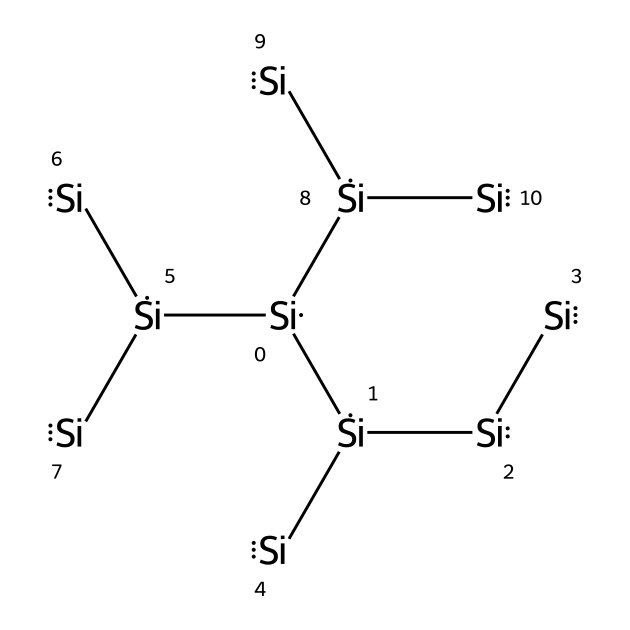What is the central atom in this structure? The SMILES representation indicates multiple silicon atoms connected in a crystalline structure. The central atom, which is consistently represented, is silicon.
Answer: silicon How many silicon atoms are in this structure? By counting the occurrences of the silicon atom symbol in the SMILES string, we find that there are ten silicon atoms total, as indicated by the nested structure.
Answer: ten What type of bonding is primarily present in this silicon structure? The structure displays covalent bonding characterized by the sharing of electrons between silicon atoms, which is typical in semiconductors due to the tetrahedral arrangement.
Answer: covalent What is the coordination number of silicon in this structure? Each silicon atom is surrounded by four other silicon atoms, which is typical for silicon in its crystalline form, thus the coordination number is four.
Answer: four What is the significance of the tetrahedral configuration of silicon in semiconductors? The tetrahedral arrangement is crucial as it allows efficient overlapping of orbitals, enabling semiconductor properties suitable for electronic applications.
Answer: efficient overlap How many layers of silicon structures are represented in this SMILES? The structural representation consists of a complex, layered arrangement, but counting distinct levels or connections shows that there are at least three layers depicted in a simplified view.
Answer: three layers Is this the most stable form of silicon for semiconductor applications? Yes, the crystalline form represented is the most stable allotrope of silicon, known as cubic diamond structure, commonly used in semiconductor applications.
Answer: yes 